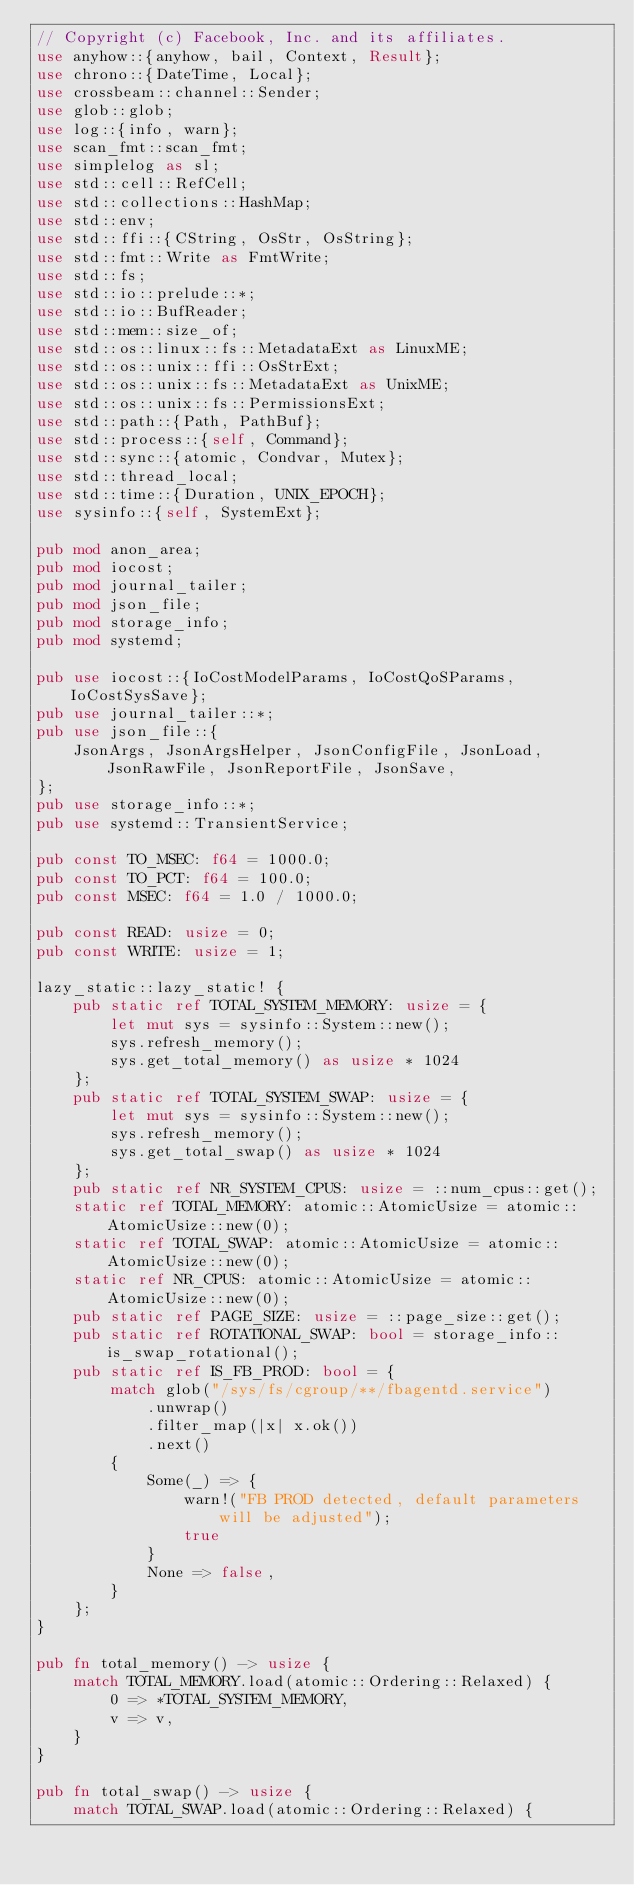Convert code to text. <code><loc_0><loc_0><loc_500><loc_500><_Rust_>// Copyright (c) Facebook, Inc. and its affiliates.
use anyhow::{anyhow, bail, Context, Result};
use chrono::{DateTime, Local};
use crossbeam::channel::Sender;
use glob::glob;
use log::{info, warn};
use scan_fmt::scan_fmt;
use simplelog as sl;
use std::cell::RefCell;
use std::collections::HashMap;
use std::env;
use std::ffi::{CString, OsStr, OsString};
use std::fmt::Write as FmtWrite;
use std::fs;
use std::io::prelude::*;
use std::io::BufReader;
use std::mem::size_of;
use std::os::linux::fs::MetadataExt as LinuxME;
use std::os::unix::ffi::OsStrExt;
use std::os::unix::fs::MetadataExt as UnixME;
use std::os::unix::fs::PermissionsExt;
use std::path::{Path, PathBuf};
use std::process::{self, Command};
use std::sync::{atomic, Condvar, Mutex};
use std::thread_local;
use std::time::{Duration, UNIX_EPOCH};
use sysinfo::{self, SystemExt};

pub mod anon_area;
pub mod iocost;
pub mod journal_tailer;
pub mod json_file;
pub mod storage_info;
pub mod systemd;

pub use iocost::{IoCostModelParams, IoCostQoSParams, IoCostSysSave};
pub use journal_tailer::*;
pub use json_file::{
    JsonArgs, JsonArgsHelper, JsonConfigFile, JsonLoad, JsonRawFile, JsonReportFile, JsonSave,
};
pub use storage_info::*;
pub use systemd::TransientService;

pub const TO_MSEC: f64 = 1000.0;
pub const TO_PCT: f64 = 100.0;
pub const MSEC: f64 = 1.0 / 1000.0;

pub const READ: usize = 0;
pub const WRITE: usize = 1;

lazy_static::lazy_static! {
    pub static ref TOTAL_SYSTEM_MEMORY: usize = {
        let mut sys = sysinfo::System::new();
        sys.refresh_memory();
        sys.get_total_memory() as usize * 1024
    };
    pub static ref TOTAL_SYSTEM_SWAP: usize = {
        let mut sys = sysinfo::System::new();
        sys.refresh_memory();
        sys.get_total_swap() as usize * 1024
    };
    pub static ref NR_SYSTEM_CPUS: usize = ::num_cpus::get();
    static ref TOTAL_MEMORY: atomic::AtomicUsize = atomic::AtomicUsize::new(0);
    static ref TOTAL_SWAP: atomic::AtomicUsize = atomic::AtomicUsize::new(0);
    static ref NR_CPUS: atomic::AtomicUsize = atomic::AtomicUsize::new(0);
    pub static ref PAGE_SIZE: usize = ::page_size::get();
    pub static ref ROTATIONAL_SWAP: bool = storage_info::is_swap_rotational();
    pub static ref IS_FB_PROD: bool = {
        match glob("/sys/fs/cgroup/**/fbagentd.service")
            .unwrap()
            .filter_map(|x| x.ok())
            .next()
        {
            Some(_) => {
                warn!("FB PROD detected, default parameters will be adjusted");
                true
            }
            None => false,
        }
    };
}

pub fn total_memory() -> usize {
    match TOTAL_MEMORY.load(atomic::Ordering::Relaxed) {
        0 => *TOTAL_SYSTEM_MEMORY,
        v => v,
    }
}

pub fn total_swap() -> usize {
    match TOTAL_SWAP.load(atomic::Ordering::Relaxed) {</code> 